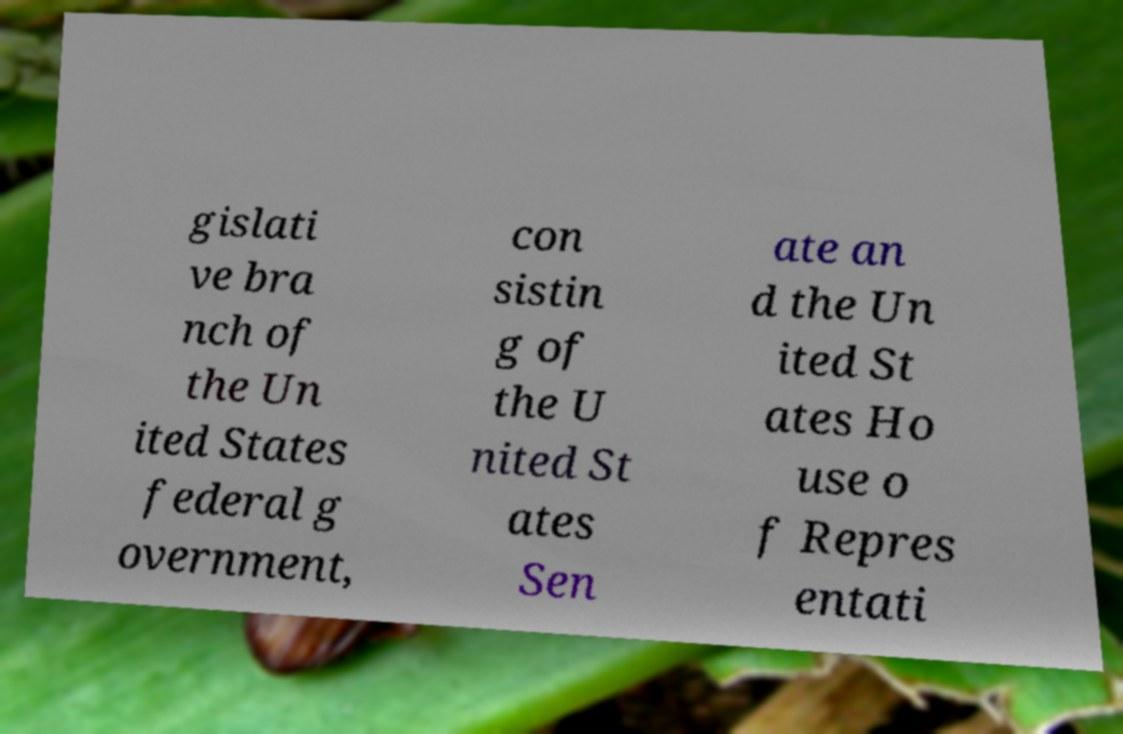There's text embedded in this image that I need extracted. Can you transcribe it verbatim? gislati ve bra nch of the Un ited States federal g overnment, con sistin g of the U nited St ates Sen ate an d the Un ited St ates Ho use o f Repres entati 